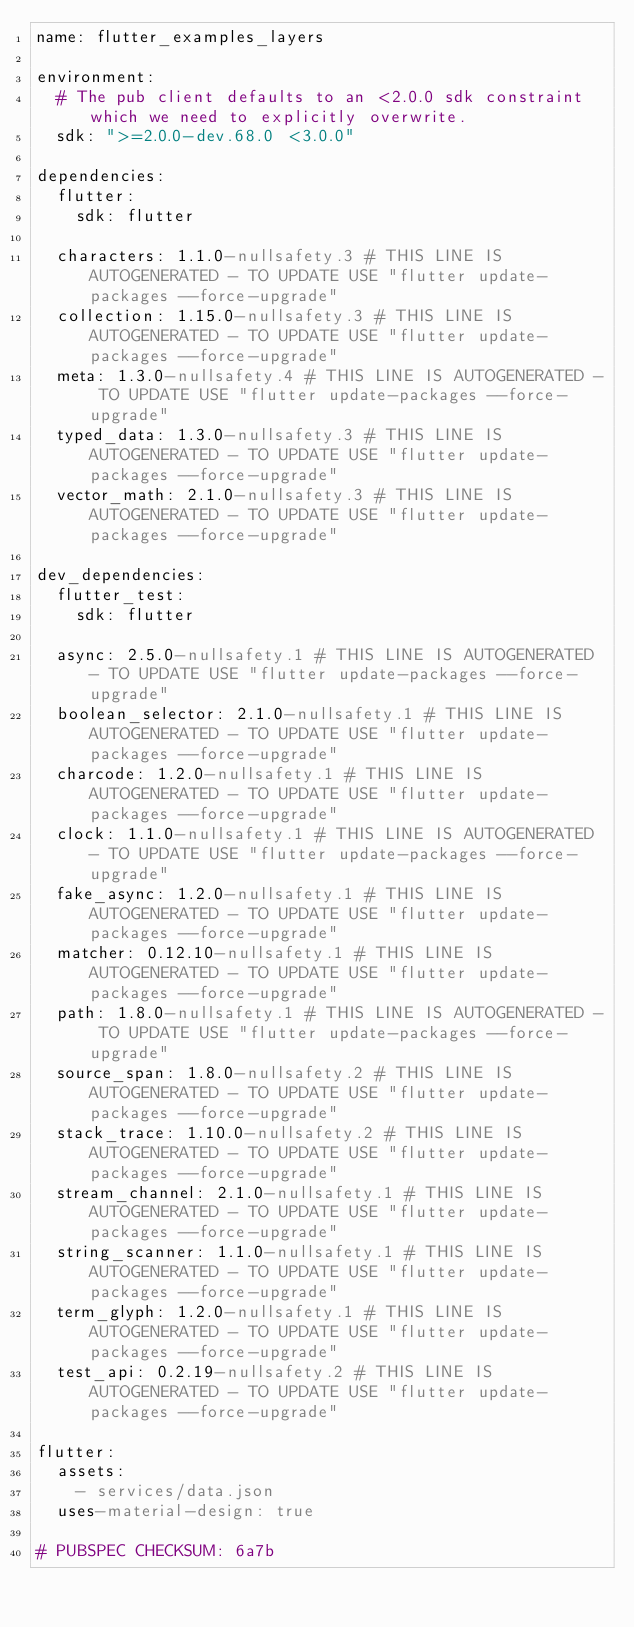<code> <loc_0><loc_0><loc_500><loc_500><_YAML_>name: flutter_examples_layers

environment:
  # The pub client defaults to an <2.0.0 sdk constraint which we need to explicitly overwrite.
  sdk: ">=2.0.0-dev.68.0 <3.0.0"

dependencies:
  flutter:
    sdk: flutter

  characters: 1.1.0-nullsafety.3 # THIS LINE IS AUTOGENERATED - TO UPDATE USE "flutter update-packages --force-upgrade"
  collection: 1.15.0-nullsafety.3 # THIS LINE IS AUTOGENERATED - TO UPDATE USE "flutter update-packages --force-upgrade"
  meta: 1.3.0-nullsafety.4 # THIS LINE IS AUTOGENERATED - TO UPDATE USE "flutter update-packages --force-upgrade"
  typed_data: 1.3.0-nullsafety.3 # THIS LINE IS AUTOGENERATED - TO UPDATE USE "flutter update-packages --force-upgrade"
  vector_math: 2.1.0-nullsafety.3 # THIS LINE IS AUTOGENERATED - TO UPDATE USE "flutter update-packages --force-upgrade"

dev_dependencies:
  flutter_test:
    sdk: flutter

  async: 2.5.0-nullsafety.1 # THIS LINE IS AUTOGENERATED - TO UPDATE USE "flutter update-packages --force-upgrade"
  boolean_selector: 2.1.0-nullsafety.1 # THIS LINE IS AUTOGENERATED - TO UPDATE USE "flutter update-packages --force-upgrade"
  charcode: 1.2.0-nullsafety.1 # THIS LINE IS AUTOGENERATED - TO UPDATE USE "flutter update-packages --force-upgrade"
  clock: 1.1.0-nullsafety.1 # THIS LINE IS AUTOGENERATED - TO UPDATE USE "flutter update-packages --force-upgrade"
  fake_async: 1.2.0-nullsafety.1 # THIS LINE IS AUTOGENERATED - TO UPDATE USE "flutter update-packages --force-upgrade"
  matcher: 0.12.10-nullsafety.1 # THIS LINE IS AUTOGENERATED - TO UPDATE USE "flutter update-packages --force-upgrade"
  path: 1.8.0-nullsafety.1 # THIS LINE IS AUTOGENERATED - TO UPDATE USE "flutter update-packages --force-upgrade"
  source_span: 1.8.0-nullsafety.2 # THIS LINE IS AUTOGENERATED - TO UPDATE USE "flutter update-packages --force-upgrade"
  stack_trace: 1.10.0-nullsafety.2 # THIS LINE IS AUTOGENERATED - TO UPDATE USE "flutter update-packages --force-upgrade"
  stream_channel: 2.1.0-nullsafety.1 # THIS LINE IS AUTOGENERATED - TO UPDATE USE "flutter update-packages --force-upgrade"
  string_scanner: 1.1.0-nullsafety.1 # THIS LINE IS AUTOGENERATED - TO UPDATE USE "flutter update-packages --force-upgrade"
  term_glyph: 1.2.0-nullsafety.1 # THIS LINE IS AUTOGENERATED - TO UPDATE USE "flutter update-packages --force-upgrade"
  test_api: 0.2.19-nullsafety.2 # THIS LINE IS AUTOGENERATED - TO UPDATE USE "flutter update-packages --force-upgrade"

flutter:
  assets:
    - services/data.json
  uses-material-design: true

# PUBSPEC CHECKSUM: 6a7b
</code> 